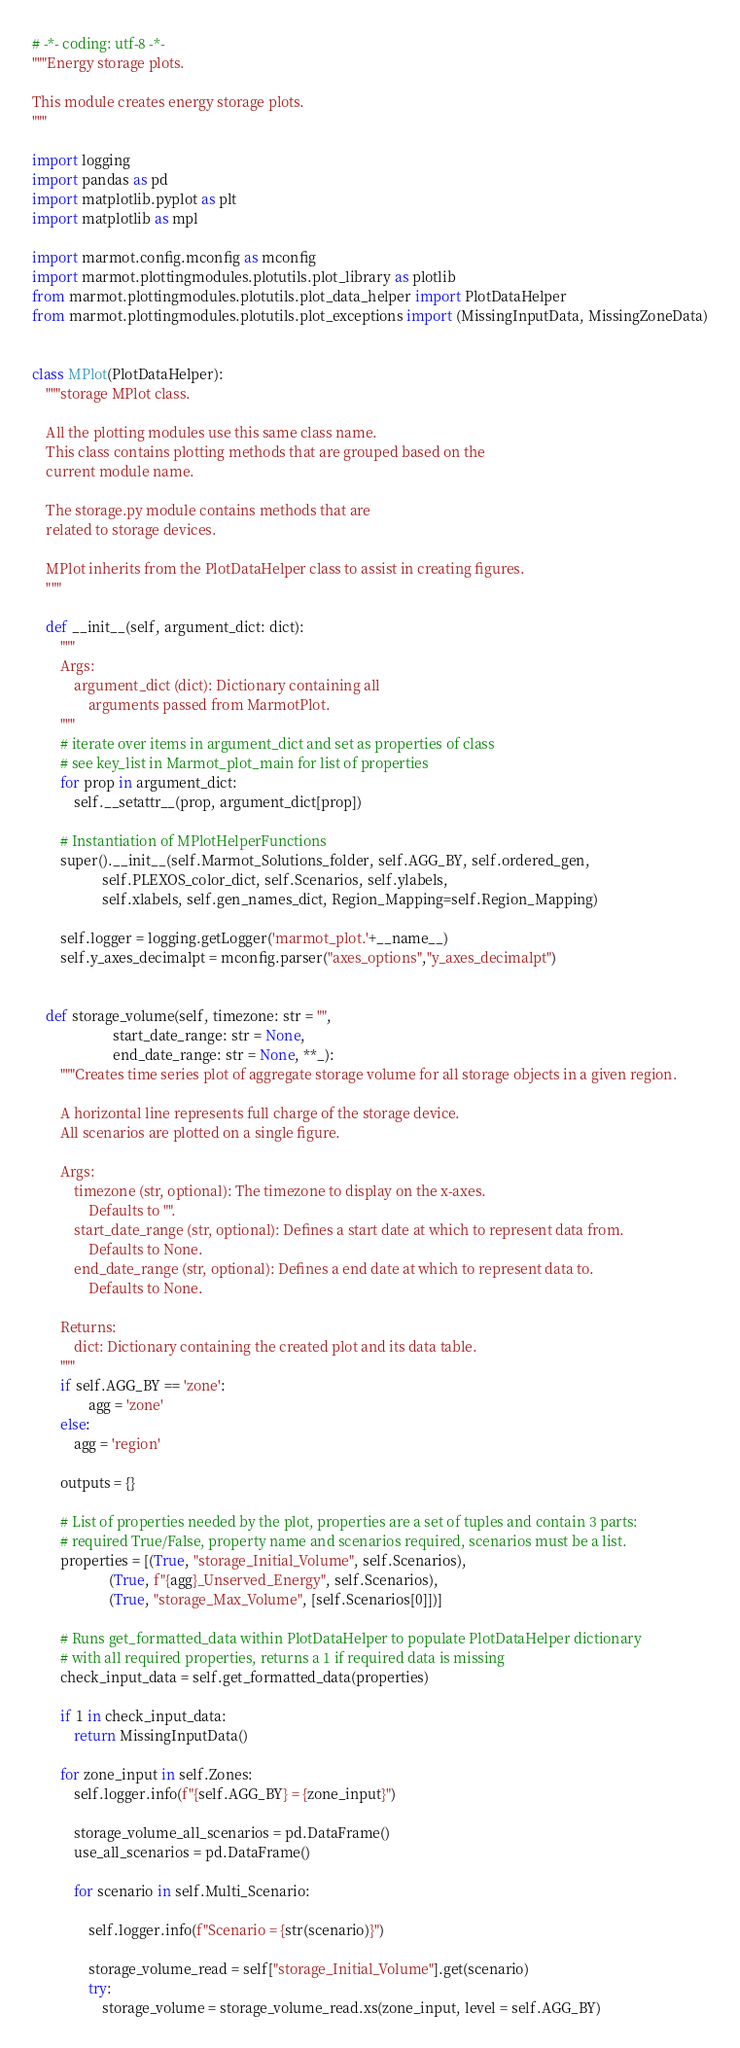<code> <loc_0><loc_0><loc_500><loc_500><_Python_># -*- coding: utf-8 -*-
"""Energy storage plots.

This module creates energy storage plots.
"""

import logging
import pandas as pd
import matplotlib.pyplot as plt
import matplotlib as mpl

import marmot.config.mconfig as mconfig
import marmot.plottingmodules.plotutils.plot_library as plotlib
from marmot.plottingmodules.plotutils.plot_data_helper import PlotDataHelper
from marmot.plottingmodules.plotutils.plot_exceptions import (MissingInputData, MissingZoneData)


class MPlot(PlotDataHelper):
    """storage MPlot class.

    All the plotting modules use this same class name.
    This class contains plotting methods that are grouped based on the
    current module name.
    
    The storage.py module contains methods that are
    related to storage devices. 
   
    MPlot inherits from the PlotDataHelper class to assist in creating figures.
    """

    def __init__(self, argument_dict: dict):
        """
        Args:
            argument_dict (dict): Dictionary containing all
                arguments passed from MarmotPlot.
        """
        # iterate over items in argument_dict and set as properties of class
        # see key_list in Marmot_plot_main for list of properties
        for prop in argument_dict:
            self.__setattr__(prop, argument_dict[prop])
        
        # Instantiation of MPlotHelperFunctions
        super().__init__(self.Marmot_Solutions_folder, self.AGG_BY, self.ordered_gen, 
                    self.PLEXOS_color_dict, self.Scenarios, self.ylabels, 
                    self.xlabels, self.gen_names_dict, Region_Mapping=self.Region_Mapping) 

        self.logger = logging.getLogger('marmot_plot.'+__name__)
        self.y_axes_decimalpt = mconfig.parser("axes_options","y_axes_decimalpt")
        

    def storage_volume(self, timezone: str = "", 
                       start_date_range: str = None, 
                       end_date_range: str = None, **_):
        """Creates time series plot of aggregate storage volume for all storage objects in a given region.

        A horizontal line represents full charge of the storage device.
        All scenarios are plotted on a single figure.

        Args:
            timezone (str, optional): The timezone to display on the x-axes.
                Defaults to "".
            start_date_range (str, optional): Defines a start date at which to represent data from. 
                Defaults to None.
            end_date_range (str, optional): Defines a end date at which to represent data to.
                Defaults to None.

        Returns:
            dict: Dictionary containing the created plot and its data table.
        """
        if self.AGG_BY == 'zone':
                agg = 'zone'
        else:
            agg = 'region'
            
        outputs = {}
        
        # List of properties needed by the plot, properties are a set of tuples and contain 3 parts:
        # required True/False, property name and scenarios required, scenarios must be a list.
        properties = [(True, "storage_Initial_Volume", self.Scenarios),
                      (True, f"{agg}_Unserved_Energy", self.Scenarios),
                      (True, "storage_Max_Volume", [self.Scenarios[0]])]
        
        # Runs get_formatted_data within PlotDataHelper to populate PlotDataHelper dictionary  
        # with all required properties, returns a 1 if required data is missing
        check_input_data = self.get_formatted_data(properties)

        if 1 in check_input_data:
            return MissingInputData()
        
        for zone_input in self.Zones:
            self.logger.info(f"{self.AGG_BY} = {zone_input}")

            storage_volume_all_scenarios = pd.DataFrame()
            use_all_scenarios = pd.DataFrame()

            for scenario in self.Multi_Scenario:

                self.logger.info(f"Scenario = {str(scenario)}")

                storage_volume_read = self["storage_Initial_Volume"].get(scenario)
                try:
                    storage_volume = storage_volume_read.xs(zone_input, level = self.AGG_BY)</code> 